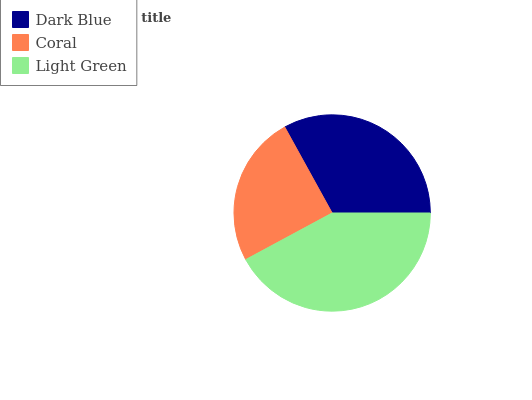Is Coral the minimum?
Answer yes or no. Yes. Is Light Green the maximum?
Answer yes or no. Yes. Is Light Green the minimum?
Answer yes or no. No. Is Coral the maximum?
Answer yes or no. No. Is Light Green greater than Coral?
Answer yes or no. Yes. Is Coral less than Light Green?
Answer yes or no. Yes. Is Coral greater than Light Green?
Answer yes or no. No. Is Light Green less than Coral?
Answer yes or no. No. Is Dark Blue the high median?
Answer yes or no. Yes. Is Dark Blue the low median?
Answer yes or no. Yes. Is Coral the high median?
Answer yes or no. No. Is Light Green the low median?
Answer yes or no. No. 